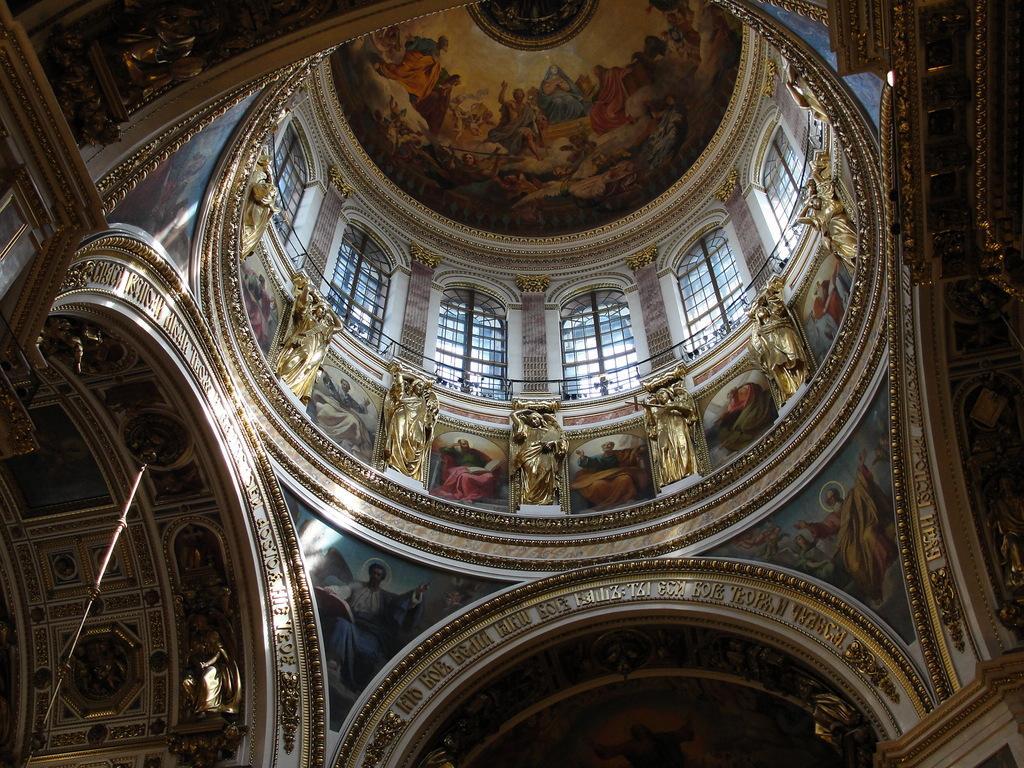Can you describe this image briefly? In this picture I can see the inside view of a building and I see the sculptures in the center of the image. In the background I see the windows and I see the art on the ceiling. 